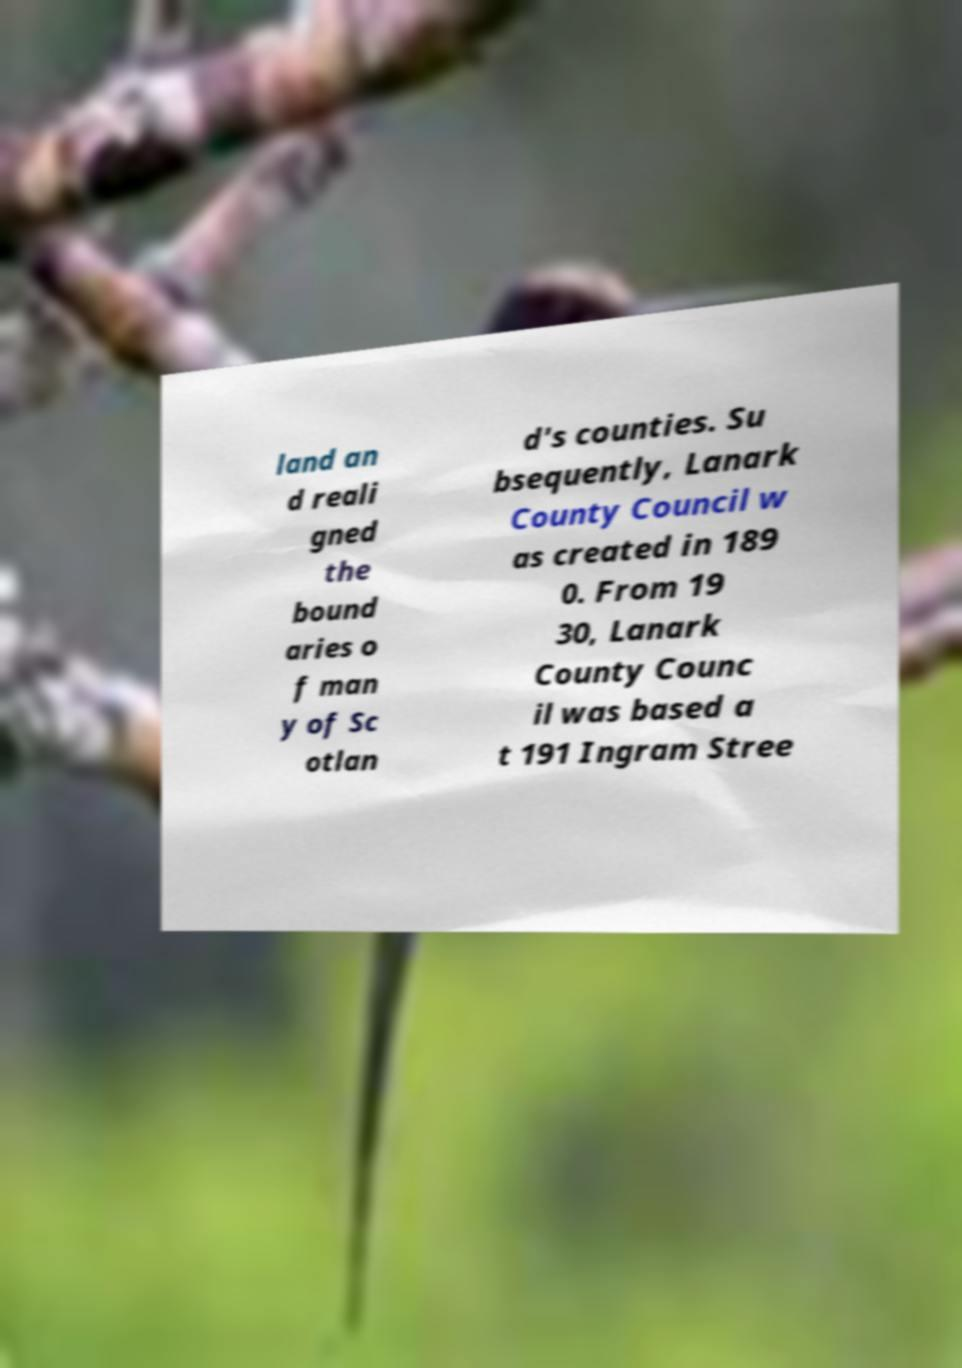Could you assist in decoding the text presented in this image and type it out clearly? land an d reali gned the bound aries o f man y of Sc otlan d's counties. Su bsequently, Lanark County Council w as created in 189 0. From 19 30, Lanark County Counc il was based a t 191 Ingram Stree 